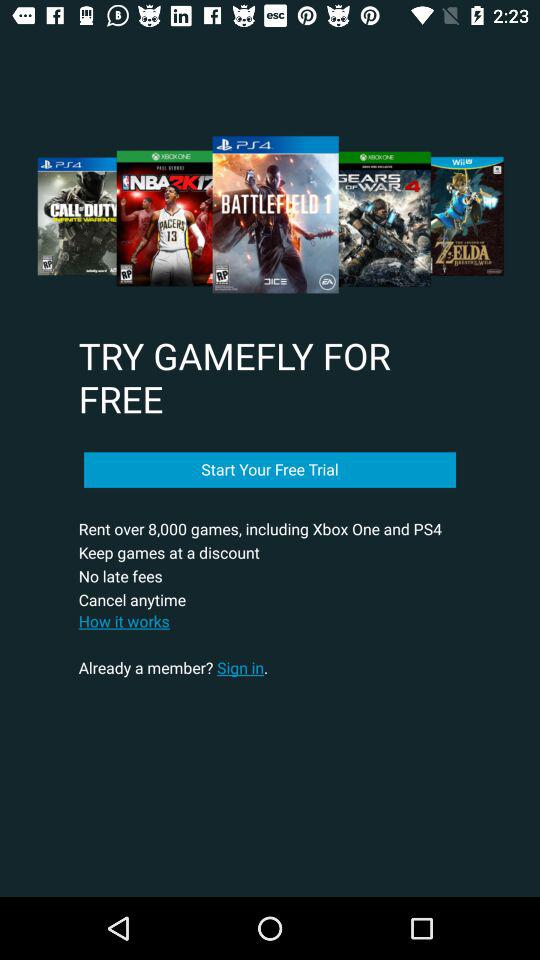What is the name of the application? The name of the application is "GAMEFLY". 